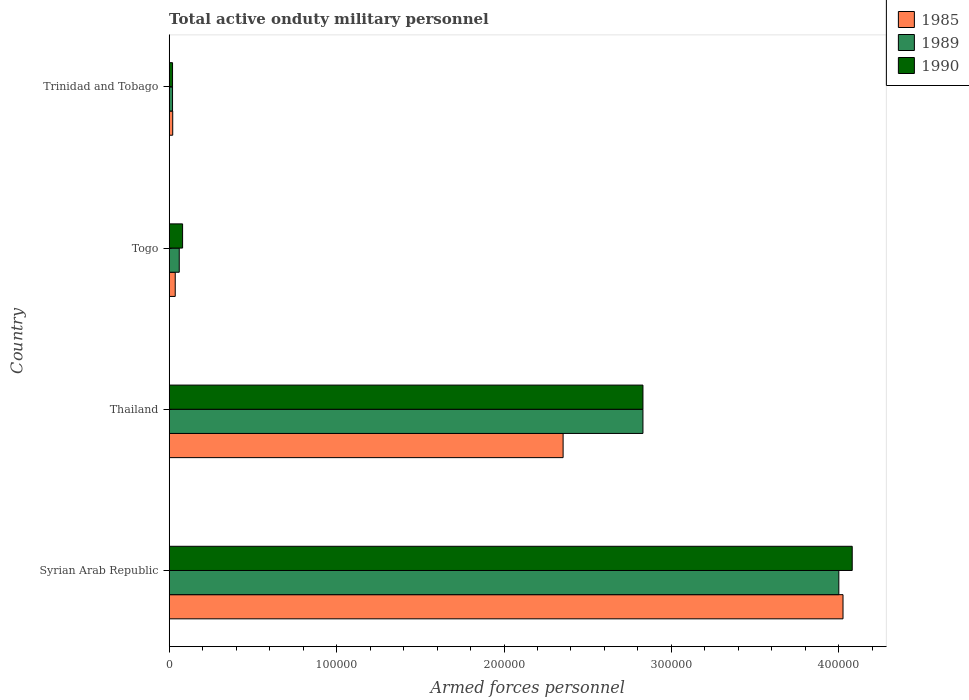How many different coloured bars are there?
Provide a short and direct response. 3. How many groups of bars are there?
Give a very brief answer. 4. Are the number of bars on each tick of the Y-axis equal?
Provide a succinct answer. Yes. How many bars are there on the 2nd tick from the top?
Offer a terse response. 3. How many bars are there on the 3rd tick from the bottom?
Offer a very short reply. 3. What is the label of the 4th group of bars from the top?
Offer a terse response. Syrian Arab Republic. In how many cases, is the number of bars for a given country not equal to the number of legend labels?
Your response must be concise. 0. What is the number of armed forces personnel in 1989 in Syrian Arab Republic?
Your answer should be compact. 4.00e+05. Across all countries, what is the maximum number of armed forces personnel in 1985?
Give a very brief answer. 4.02e+05. In which country was the number of armed forces personnel in 1985 maximum?
Your response must be concise. Syrian Arab Republic. In which country was the number of armed forces personnel in 1990 minimum?
Offer a very short reply. Trinidad and Tobago. What is the total number of armed forces personnel in 1985 in the graph?
Provide a succinct answer. 6.44e+05. What is the difference between the number of armed forces personnel in 1989 in Syrian Arab Republic and that in Thailand?
Give a very brief answer. 1.17e+05. What is the difference between the number of armed forces personnel in 1990 in Togo and the number of armed forces personnel in 1989 in Syrian Arab Republic?
Give a very brief answer. -3.92e+05. What is the average number of armed forces personnel in 1989 per country?
Make the answer very short. 1.73e+05. What is the difference between the number of armed forces personnel in 1990 and number of armed forces personnel in 1985 in Trinidad and Tobago?
Your answer should be very brief. -100. In how many countries, is the number of armed forces personnel in 1985 greater than 340000 ?
Make the answer very short. 1. What is the ratio of the number of armed forces personnel in 1985 in Togo to that in Trinidad and Tobago?
Your answer should be compact. 1.71. What is the difference between the highest and the second highest number of armed forces personnel in 1985?
Offer a terse response. 1.67e+05. What is the difference between the highest and the lowest number of armed forces personnel in 1990?
Keep it short and to the point. 4.06e+05. Is the sum of the number of armed forces personnel in 1985 in Syrian Arab Republic and Thailand greater than the maximum number of armed forces personnel in 1990 across all countries?
Keep it short and to the point. Yes. What does the 3rd bar from the top in Trinidad and Tobago represents?
Keep it short and to the point. 1985. What does the 3rd bar from the bottom in Syrian Arab Republic represents?
Give a very brief answer. 1990. How many bars are there?
Offer a terse response. 12. Are all the bars in the graph horizontal?
Make the answer very short. Yes. Are the values on the major ticks of X-axis written in scientific E-notation?
Keep it short and to the point. No. Does the graph contain any zero values?
Make the answer very short. No. Does the graph contain grids?
Your answer should be very brief. No. Where does the legend appear in the graph?
Provide a short and direct response. Top right. How many legend labels are there?
Your answer should be compact. 3. How are the legend labels stacked?
Your response must be concise. Vertical. What is the title of the graph?
Ensure brevity in your answer.  Total active onduty military personnel. What is the label or title of the X-axis?
Give a very brief answer. Armed forces personnel. What is the Armed forces personnel of 1985 in Syrian Arab Republic?
Ensure brevity in your answer.  4.02e+05. What is the Armed forces personnel in 1990 in Syrian Arab Republic?
Your answer should be very brief. 4.08e+05. What is the Armed forces personnel of 1985 in Thailand?
Give a very brief answer. 2.35e+05. What is the Armed forces personnel of 1989 in Thailand?
Ensure brevity in your answer.  2.83e+05. What is the Armed forces personnel in 1990 in Thailand?
Your response must be concise. 2.83e+05. What is the Armed forces personnel of 1985 in Togo?
Keep it short and to the point. 3600. What is the Armed forces personnel in 1989 in Togo?
Your answer should be compact. 6000. What is the Armed forces personnel of 1990 in Togo?
Your answer should be compact. 8000. What is the Armed forces personnel in 1985 in Trinidad and Tobago?
Provide a short and direct response. 2100. Across all countries, what is the maximum Armed forces personnel of 1985?
Ensure brevity in your answer.  4.02e+05. Across all countries, what is the maximum Armed forces personnel in 1990?
Keep it short and to the point. 4.08e+05. Across all countries, what is the minimum Armed forces personnel of 1985?
Provide a short and direct response. 2100. Across all countries, what is the minimum Armed forces personnel of 1990?
Give a very brief answer. 2000. What is the total Armed forces personnel in 1985 in the graph?
Your answer should be compact. 6.44e+05. What is the total Armed forces personnel of 1989 in the graph?
Provide a succinct answer. 6.91e+05. What is the total Armed forces personnel of 1990 in the graph?
Provide a succinct answer. 7.01e+05. What is the difference between the Armed forces personnel of 1985 in Syrian Arab Republic and that in Thailand?
Give a very brief answer. 1.67e+05. What is the difference between the Armed forces personnel of 1989 in Syrian Arab Republic and that in Thailand?
Provide a short and direct response. 1.17e+05. What is the difference between the Armed forces personnel of 1990 in Syrian Arab Republic and that in Thailand?
Ensure brevity in your answer.  1.25e+05. What is the difference between the Armed forces personnel in 1985 in Syrian Arab Republic and that in Togo?
Your answer should be very brief. 3.99e+05. What is the difference between the Armed forces personnel in 1989 in Syrian Arab Republic and that in Togo?
Your answer should be compact. 3.94e+05. What is the difference between the Armed forces personnel in 1990 in Syrian Arab Republic and that in Togo?
Offer a very short reply. 4.00e+05. What is the difference between the Armed forces personnel in 1985 in Syrian Arab Republic and that in Trinidad and Tobago?
Offer a terse response. 4.00e+05. What is the difference between the Armed forces personnel of 1989 in Syrian Arab Republic and that in Trinidad and Tobago?
Your response must be concise. 3.98e+05. What is the difference between the Armed forces personnel in 1990 in Syrian Arab Republic and that in Trinidad and Tobago?
Keep it short and to the point. 4.06e+05. What is the difference between the Armed forces personnel in 1985 in Thailand and that in Togo?
Your answer should be compact. 2.32e+05. What is the difference between the Armed forces personnel in 1989 in Thailand and that in Togo?
Your answer should be compact. 2.77e+05. What is the difference between the Armed forces personnel in 1990 in Thailand and that in Togo?
Make the answer very short. 2.75e+05. What is the difference between the Armed forces personnel of 1985 in Thailand and that in Trinidad and Tobago?
Provide a short and direct response. 2.33e+05. What is the difference between the Armed forces personnel of 1989 in Thailand and that in Trinidad and Tobago?
Ensure brevity in your answer.  2.81e+05. What is the difference between the Armed forces personnel in 1990 in Thailand and that in Trinidad and Tobago?
Ensure brevity in your answer.  2.81e+05. What is the difference between the Armed forces personnel in 1985 in Togo and that in Trinidad and Tobago?
Offer a very short reply. 1500. What is the difference between the Armed forces personnel of 1989 in Togo and that in Trinidad and Tobago?
Your answer should be compact. 4000. What is the difference between the Armed forces personnel in 1990 in Togo and that in Trinidad and Tobago?
Provide a short and direct response. 6000. What is the difference between the Armed forces personnel in 1985 in Syrian Arab Republic and the Armed forces personnel in 1989 in Thailand?
Give a very brief answer. 1.20e+05. What is the difference between the Armed forces personnel of 1985 in Syrian Arab Republic and the Armed forces personnel of 1990 in Thailand?
Give a very brief answer. 1.20e+05. What is the difference between the Armed forces personnel in 1989 in Syrian Arab Republic and the Armed forces personnel in 1990 in Thailand?
Your response must be concise. 1.17e+05. What is the difference between the Armed forces personnel of 1985 in Syrian Arab Republic and the Armed forces personnel of 1989 in Togo?
Make the answer very short. 3.96e+05. What is the difference between the Armed forces personnel in 1985 in Syrian Arab Republic and the Armed forces personnel in 1990 in Togo?
Offer a terse response. 3.94e+05. What is the difference between the Armed forces personnel in 1989 in Syrian Arab Republic and the Armed forces personnel in 1990 in Togo?
Offer a terse response. 3.92e+05. What is the difference between the Armed forces personnel of 1985 in Syrian Arab Republic and the Armed forces personnel of 1989 in Trinidad and Tobago?
Offer a very short reply. 4.00e+05. What is the difference between the Armed forces personnel in 1985 in Syrian Arab Republic and the Armed forces personnel in 1990 in Trinidad and Tobago?
Offer a terse response. 4.00e+05. What is the difference between the Armed forces personnel in 1989 in Syrian Arab Republic and the Armed forces personnel in 1990 in Trinidad and Tobago?
Provide a succinct answer. 3.98e+05. What is the difference between the Armed forces personnel in 1985 in Thailand and the Armed forces personnel in 1989 in Togo?
Your answer should be compact. 2.29e+05. What is the difference between the Armed forces personnel of 1985 in Thailand and the Armed forces personnel of 1990 in Togo?
Offer a terse response. 2.27e+05. What is the difference between the Armed forces personnel in 1989 in Thailand and the Armed forces personnel in 1990 in Togo?
Your answer should be very brief. 2.75e+05. What is the difference between the Armed forces personnel of 1985 in Thailand and the Armed forces personnel of 1989 in Trinidad and Tobago?
Your answer should be compact. 2.33e+05. What is the difference between the Armed forces personnel of 1985 in Thailand and the Armed forces personnel of 1990 in Trinidad and Tobago?
Your answer should be very brief. 2.33e+05. What is the difference between the Armed forces personnel in 1989 in Thailand and the Armed forces personnel in 1990 in Trinidad and Tobago?
Your response must be concise. 2.81e+05. What is the difference between the Armed forces personnel in 1985 in Togo and the Armed forces personnel in 1989 in Trinidad and Tobago?
Provide a short and direct response. 1600. What is the difference between the Armed forces personnel in 1985 in Togo and the Armed forces personnel in 1990 in Trinidad and Tobago?
Give a very brief answer. 1600. What is the difference between the Armed forces personnel of 1989 in Togo and the Armed forces personnel of 1990 in Trinidad and Tobago?
Ensure brevity in your answer.  4000. What is the average Armed forces personnel of 1985 per country?
Provide a succinct answer. 1.61e+05. What is the average Armed forces personnel in 1989 per country?
Provide a succinct answer. 1.73e+05. What is the average Armed forces personnel in 1990 per country?
Make the answer very short. 1.75e+05. What is the difference between the Armed forces personnel of 1985 and Armed forces personnel of 1989 in Syrian Arab Republic?
Your answer should be very brief. 2500. What is the difference between the Armed forces personnel in 1985 and Armed forces personnel in 1990 in Syrian Arab Republic?
Give a very brief answer. -5500. What is the difference between the Armed forces personnel in 1989 and Armed forces personnel in 1990 in Syrian Arab Republic?
Give a very brief answer. -8000. What is the difference between the Armed forces personnel of 1985 and Armed forces personnel of 1989 in Thailand?
Provide a succinct answer. -4.77e+04. What is the difference between the Armed forces personnel of 1985 and Armed forces personnel of 1990 in Thailand?
Provide a short and direct response. -4.77e+04. What is the difference between the Armed forces personnel in 1985 and Armed forces personnel in 1989 in Togo?
Offer a very short reply. -2400. What is the difference between the Armed forces personnel of 1985 and Armed forces personnel of 1990 in Togo?
Offer a terse response. -4400. What is the difference between the Armed forces personnel in 1989 and Armed forces personnel in 1990 in Togo?
Provide a short and direct response. -2000. What is the difference between the Armed forces personnel of 1985 and Armed forces personnel of 1989 in Trinidad and Tobago?
Offer a terse response. 100. What is the difference between the Armed forces personnel of 1989 and Armed forces personnel of 1990 in Trinidad and Tobago?
Provide a succinct answer. 0. What is the ratio of the Armed forces personnel in 1985 in Syrian Arab Republic to that in Thailand?
Provide a short and direct response. 1.71. What is the ratio of the Armed forces personnel of 1989 in Syrian Arab Republic to that in Thailand?
Give a very brief answer. 1.41. What is the ratio of the Armed forces personnel of 1990 in Syrian Arab Republic to that in Thailand?
Ensure brevity in your answer.  1.44. What is the ratio of the Armed forces personnel of 1985 in Syrian Arab Republic to that in Togo?
Provide a short and direct response. 111.81. What is the ratio of the Armed forces personnel of 1989 in Syrian Arab Republic to that in Togo?
Keep it short and to the point. 66.67. What is the ratio of the Armed forces personnel of 1990 in Syrian Arab Republic to that in Togo?
Offer a very short reply. 51. What is the ratio of the Armed forces personnel of 1985 in Syrian Arab Republic to that in Trinidad and Tobago?
Give a very brief answer. 191.67. What is the ratio of the Armed forces personnel of 1990 in Syrian Arab Republic to that in Trinidad and Tobago?
Offer a very short reply. 204. What is the ratio of the Armed forces personnel of 1985 in Thailand to that in Togo?
Your response must be concise. 65.36. What is the ratio of the Armed forces personnel in 1989 in Thailand to that in Togo?
Your response must be concise. 47.17. What is the ratio of the Armed forces personnel of 1990 in Thailand to that in Togo?
Your answer should be very brief. 35.38. What is the ratio of the Armed forces personnel in 1985 in Thailand to that in Trinidad and Tobago?
Give a very brief answer. 112.05. What is the ratio of the Armed forces personnel of 1989 in Thailand to that in Trinidad and Tobago?
Keep it short and to the point. 141.5. What is the ratio of the Armed forces personnel of 1990 in Thailand to that in Trinidad and Tobago?
Provide a succinct answer. 141.5. What is the ratio of the Armed forces personnel of 1985 in Togo to that in Trinidad and Tobago?
Provide a succinct answer. 1.71. What is the ratio of the Armed forces personnel in 1990 in Togo to that in Trinidad and Tobago?
Offer a very short reply. 4. What is the difference between the highest and the second highest Armed forces personnel of 1985?
Ensure brevity in your answer.  1.67e+05. What is the difference between the highest and the second highest Armed forces personnel in 1989?
Your answer should be compact. 1.17e+05. What is the difference between the highest and the second highest Armed forces personnel in 1990?
Provide a short and direct response. 1.25e+05. What is the difference between the highest and the lowest Armed forces personnel of 1985?
Your response must be concise. 4.00e+05. What is the difference between the highest and the lowest Armed forces personnel of 1989?
Your response must be concise. 3.98e+05. What is the difference between the highest and the lowest Armed forces personnel in 1990?
Offer a very short reply. 4.06e+05. 